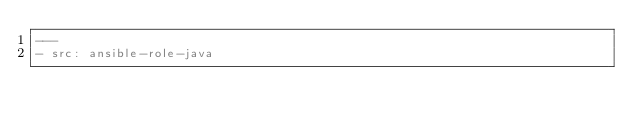Convert code to text. <code><loc_0><loc_0><loc_500><loc_500><_YAML_>---
- src: ansible-role-java
</code> 